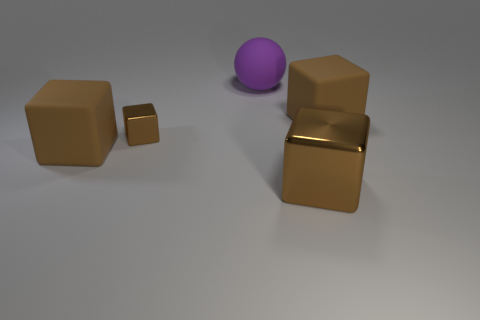What number of red things are tiny things or large matte things?
Provide a succinct answer. 0. There is a big purple object that is on the right side of the large brown object that is to the left of the large purple sphere; what is its shape?
Offer a very short reply. Sphere. There is a brown matte block behind the small thing; is it the same size as the thing to the left of the tiny brown thing?
Provide a short and direct response. Yes. Are there any small gray objects made of the same material as the big purple thing?
Offer a terse response. No. The metallic thing that is the same color as the small metal cube is what size?
Your answer should be compact. Large. There is a brown matte thing that is behind the matte block that is on the left side of the big purple rubber ball; is there a tiny brown metallic block to the left of it?
Offer a terse response. Yes. There is a purple rubber sphere; are there any purple rubber balls in front of it?
Give a very brief answer. No. There is a brown metallic block in front of the small brown metallic thing; what number of brown cubes are behind it?
Your answer should be compact. 3. There is a purple rubber ball; does it have the same size as the matte object that is on the left side of the large purple rubber ball?
Give a very brief answer. Yes. Are there any objects that have the same color as the rubber sphere?
Your answer should be compact. No. 